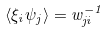<formula> <loc_0><loc_0><loc_500><loc_500>\langle \xi _ { i } \psi _ { j } \rangle = w _ { j i } ^ { - 1 }</formula> 